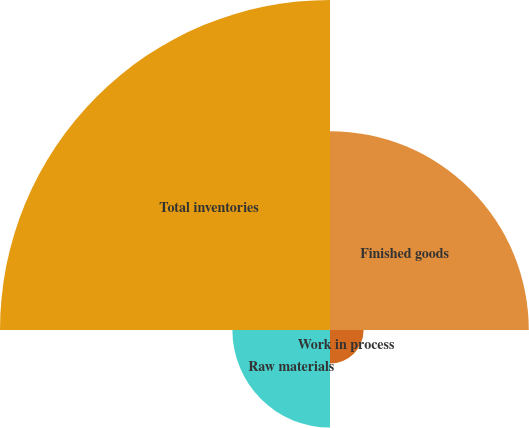<chart> <loc_0><loc_0><loc_500><loc_500><pie_chart><fcel>Finished goods<fcel>Work in process<fcel>Raw materials<fcel>Total inventories<nl><fcel>30.12%<fcel>5.09%<fcel>14.79%<fcel>50.0%<nl></chart> 